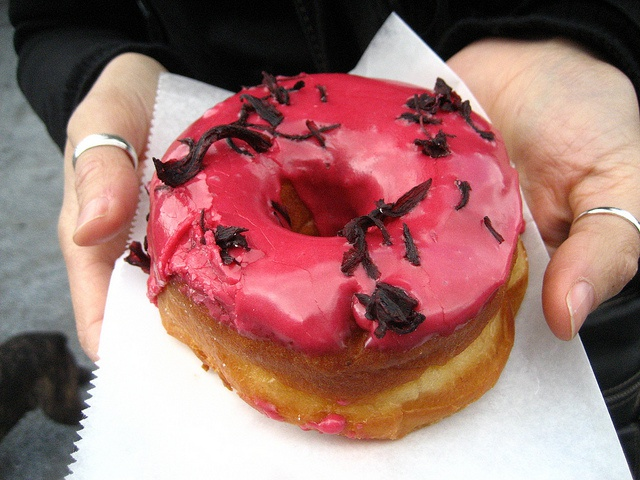Describe the objects in this image and their specific colors. I can see donut in black, salmon, maroon, and brown tones, people in black, tan, and brown tones, and dog in black and gray tones in this image. 